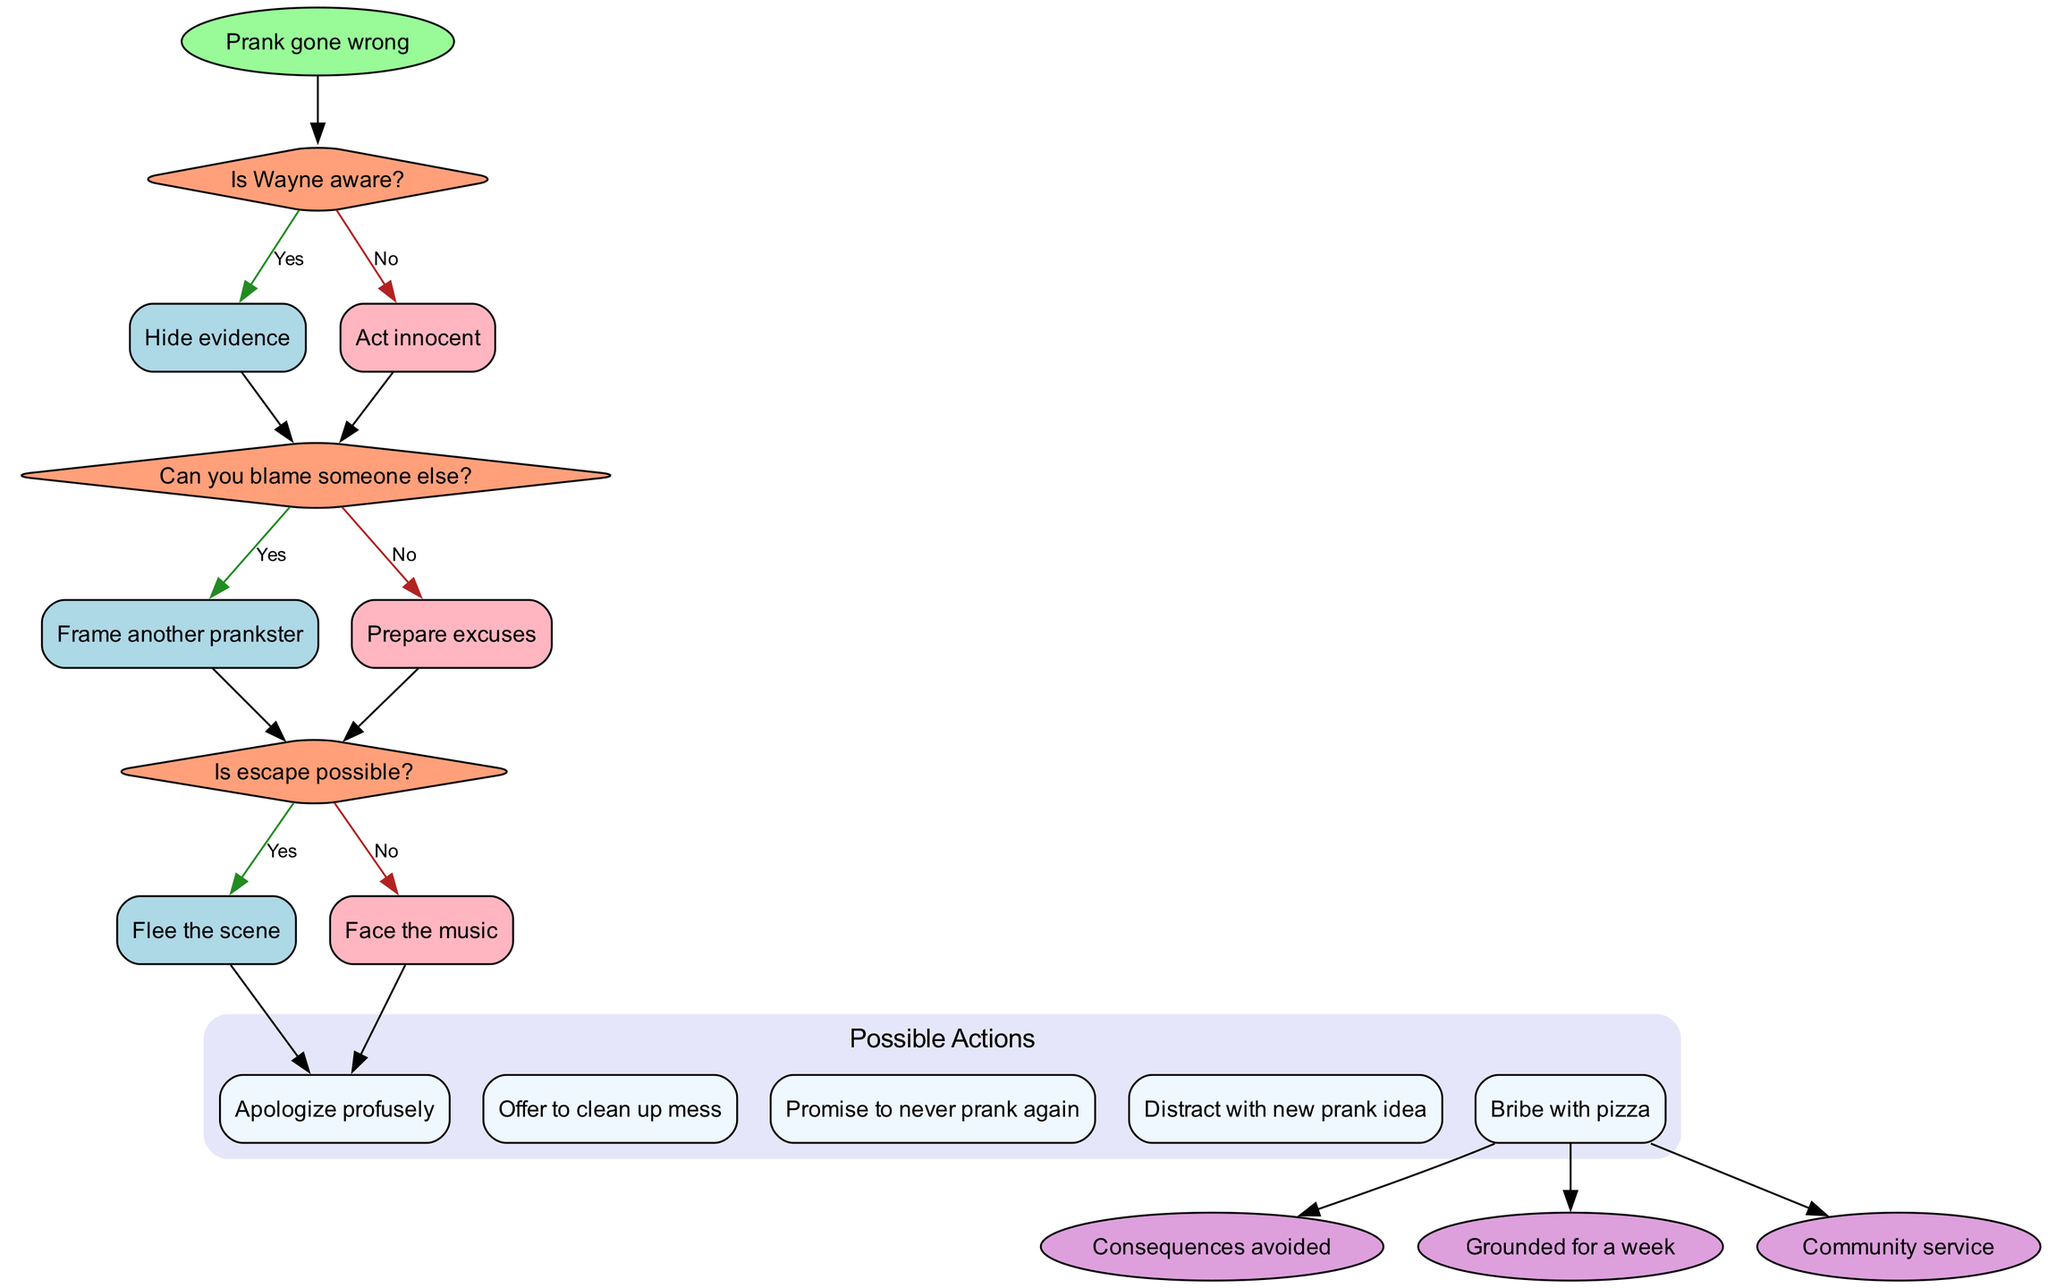What is the starting point of this flowchart? The diagram indicates that the starting point is marked as "Prank gone wrong." This is the initial node from which the flow of decisions and actions begins.
Answer: Prank gone wrong How many decision nodes are present in the flowchart? There are three decision nodes within the flowchart. Each decision node corresponds to a specific choice regarding the prank situation, and they are clearly labeled in the diagram.
Answer: 3 What action follows if the answer to "Is Wayne aware?" is yes? If "Is Wayne aware?" is answered with yes, the next action taken is to "Hide evidence." This action is indicated as the response to this specific decision node.
Answer: Hide evidence What happens at the last decision node if escape is possible? The last decision node regarding whether escape is possible leads to the action of "Flee the scene" if answered with yes. This means if escape can be achieved, the suggested action is to leave quickly.
Answer: Flee the scene What is the consequence if one cannot escape and has to face the music? If faced with the music after determining that escape is not possible, the consequence is to face potential outcomes such as being grounded for a week or doing community service.
Answer: Community service 